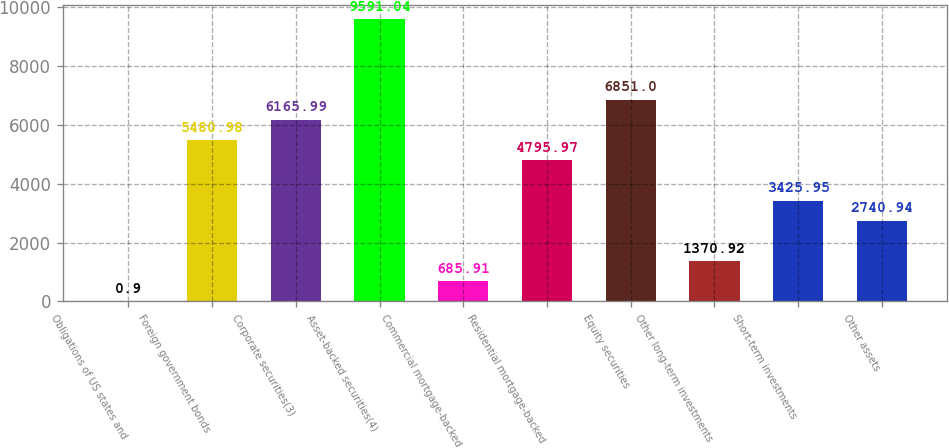Convert chart. <chart><loc_0><loc_0><loc_500><loc_500><bar_chart><fcel>Obligations of US states and<fcel>Foreign government bonds<fcel>Corporate securities(3)<fcel>Asset-backed securities(4)<fcel>Commercial mortgage-backed<fcel>Residential mortgage-backed<fcel>Equity securities<fcel>Other long-term investments<fcel>Short-term investments<fcel>Other assets<nl><fcel>0.9<fcel>5480.98<fcel>6165.99<fcel>9591.04<fcel>685.91<fcel>4795.97<fcel>6851<fcel>1370.92<fcel>3425.95<fcel>2740.94<nl></chart> 